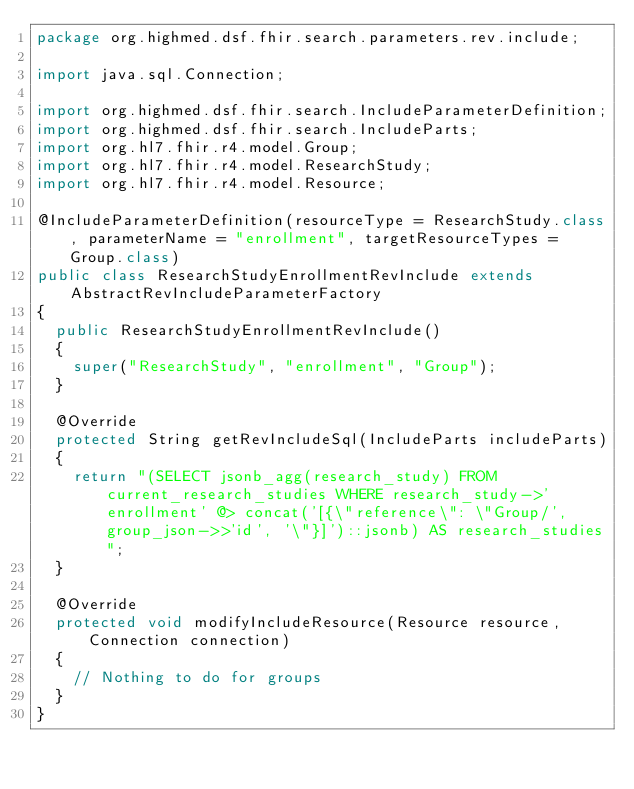Convert code to text. <code><loc_0><loc_0><loc_500><loc_500><_Java_>package org.highmed.dsf.fhir.search.parameters.rev.include;

import java.sql.Connection;

import org.highmed.dsf.fhir.search.IncludeParameterDefinition;
import org.highmed.dsf.fhir.search.IncludeParts;
import org.hl7.fhir.r4.model.Group;
import org.hl7.fhir.r4.model.ResearchStudy;
import org.hl7.fhir.r4.model.Resource;

@IncludeParameterDefinition(resourceType = ResearchStudy.class, parameterName = "enrollment", targetResourceTypes = Group.class)
public class ResearchStudyEnrollmentRevInclude extends AbstractRevIncludeParameterFactory
{
	public ResearchStudyEnrollmentRevInclude()
	{
		super("ResearchStudy", "enrollment", "Group");
	}

	@Override
	protected String getRevIncludeSql(IncludeParts includeParts)
	{
		return "(SELECT jsonb_agg(research_study) FROM current_research_studies WHERE research_study->'enrollment' @> concat('[{\"reference\": \"Group/', group_json->>'id', '\"}]')::jsonb) AS research_studies";
	}

	@Override
	protected void modifyIncludeResource(Resource resource, Connection connection)
	{
		// Nothing to do for groups
	}
}
</code> 